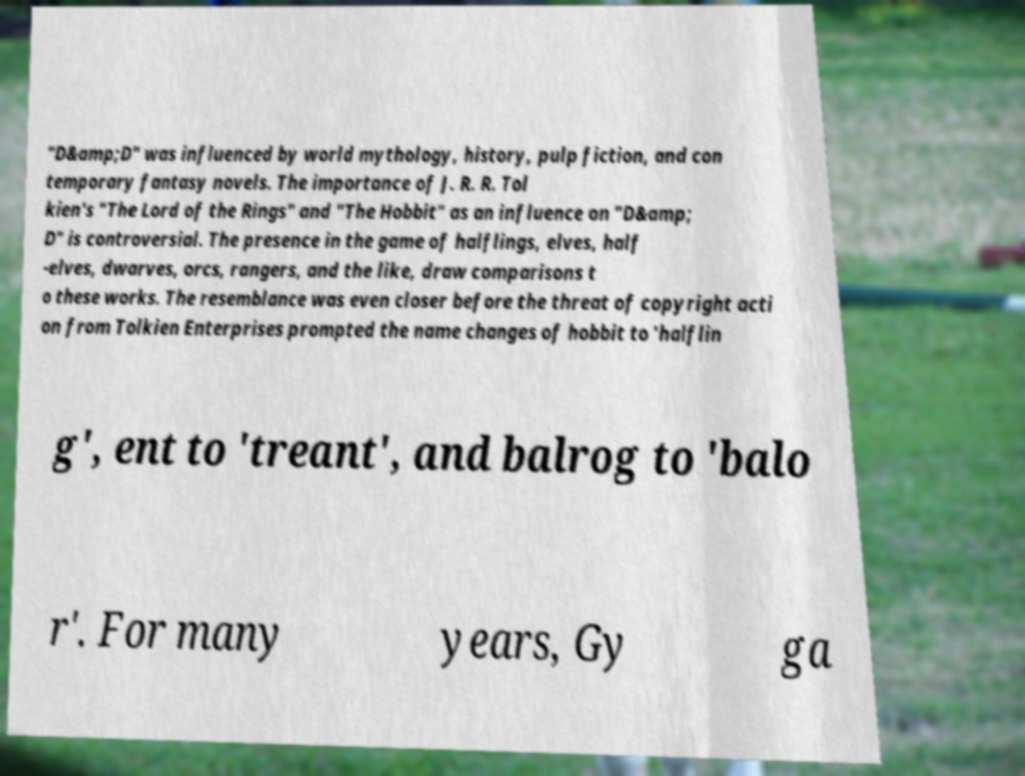What messages or text are displayed in this image? I need them in a readable, typed format. "D&amp;D" was influenced by world mythology, history, pulp fiction, and con temporary fantasy novels. The importance of J. R. R. Tol kien's "The Lord of the Rings" and "The Hobbit" as an influence on "D&amp; D" is controversial. The presence in the game of halflings, elves, half -elves, dwarves, orcs, rangers, and the like, draw comparisons t o these works. The resemblance was even closer before the threat of copyright acti on from Tolkien Enterprises prompted the name changes of hobbit to 'halflin g', ent to 'treant', and balrog to 'balo r'. For many years, Gy ga 